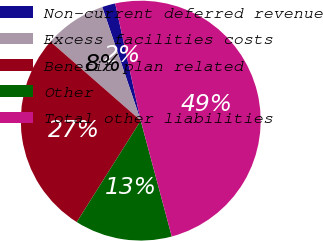Convert chart. <chart><loc_0><loc_0><loc_500><loc_500><pie_chart><fcel>Non-current deferred revenue<fcel>Excess facilities costs<fcel>Benefit plan related<fcel>Other<fcel>Total other liabilities<nl><fcel>1.78%<fcel>8.37%<fcel>27.48%<fcel>13.12%<fcel>49.25%<nl></chart> 